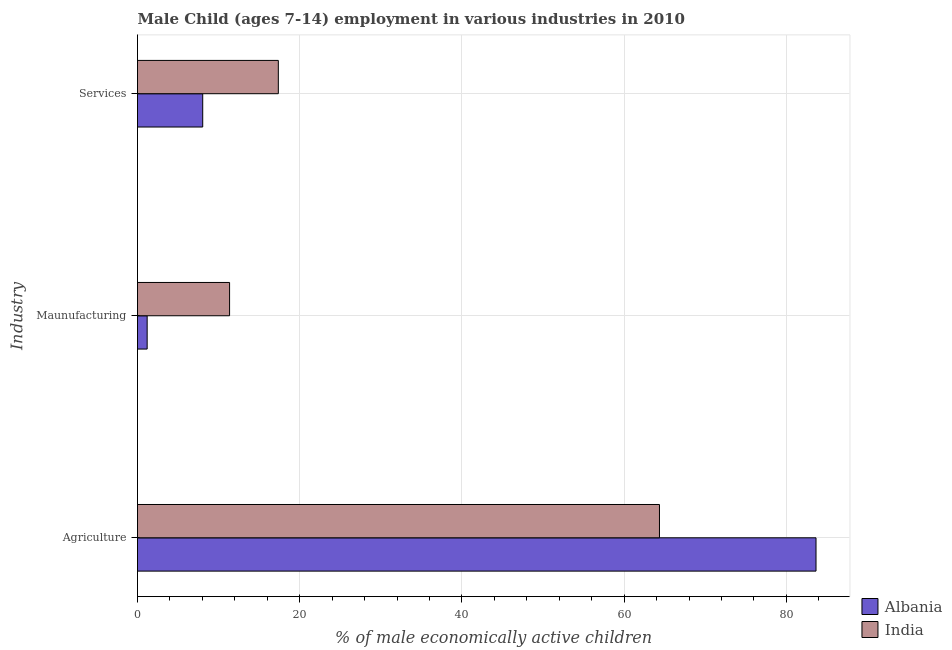What is the label of the 2nd group of bars from the top?
Provide a succinct answer. Maunufacturing. What is the percentage of economically active children in services in Albania?
Provide a short and direct response. 8.04. Across all countries, what is the maximum percentage of economically active children in services?
Keep it short and to the point. 17.36. Across all countries, what is the minimum percentage of economically active children in services?
Make the answer very short. 8.04. In which country was the percentage of economically active children in services minimum?
Provide a succinct answer. Albania. What is the total percentage of economically active children in agriculture in the graph?
Your response must be concise. 148. What is the difference between the percentage of economically active children in agriculture in India and that in Albania?
Your answer should be compact. -19.3. What is the difference between the percentage of economically active children in manufacturing in Albania and the percentage of economically active children in agriculture in India?
Ensure brevity in your answer.  -63.16. What is the difference between the percentage of economically active children in manufacturing and percentage of economically active children in agriculture in India?
Your response must be concise. -53. In how many countries, is the percentage of economically active children in manufacturing greater than 60 %?
Offer a terse response. 0. What is the ratio of the percentage of economically active children in agriculture in Albania to that in India?
Your response must be concise. 1.3. Is the percentage of economically active children in manufacturing in India less than that in Albania?
Offer a very short reply. No. What is the difference between the highest and the second highest percentage of economically active children in manufacturing?
Give a very brief answer. 10.16. What is the difference between the highest and the lowest percentage of economically active children in agriculture?
Your response must be concise. 19.3. In how many countries, is the percentage of economically active children in manufacturing greater than the average percentage of economically active children in manufacturing taken over all countries?
Keep it short and to the point. 1. What does the 1st bar from the top in Services represents?
Keep it short and to the point. India. What does the 2nd bar from the bottom in Services represents?
Make the answer very short. India. How many countries are there in the graph?
Your answer should be compact. 2. What is the difference between two consecutive major ticks on the X-axis?
Offer a terse response. 20. Are the values on the major ticks of X-axis written in scientific E-notation?
Provide a succinct answer. No. Does the graph contain any zero values?
Ensure brevity in your answer.  No. Where does the legend appear in the graph?
Offer a very short reply. Bottom right. How are the legend labels stacked?
Your answer should be compact. Vertical. What is the title of the graph?
Offer a terse response. Male Child (ages 7-14) employment in various industries in 2010. What is the label or title of the X-axis?
Provide a succinct answer. % of male economically active children. What is the label or title of the Y-axis?
Your response must be concise. Industry. What is the % of male economically active children in Albania in Agriculture?
Your answer should be compact. 83.65. What is the % of male economically active children of India in Agriculture?
Ensure brevity in your answer.  64.35. What is the % of male economically active children of Albania in Maunufacturing?
Ensure brevity in your answer.  1.19. What is the % of male economically active children of India in Maunufacturing?
Your answer should be compact. 11.35. What is the % of male economically active children in Albania in Services?
Provide a short and direct response. 8.04. What is the % of male economically active children of India in Services?
Offer a terse response. 17.36. Across all Industry, what is the maximum % of male economically active children in Albania?
Provide a short and direct response. 83.65. Across all Industry, what is the maximum % of male economically active children in India?
Offer a terse response. 64.35. Across all Industry, what is the minimum % of male economically active children of Albania?
Provide a short and direct response. 1.19. Across all Industry, what is the minimum % of male economically active children of India?
Offer a very short reply. 11.35. What is the total % of male economically active children in Albania in the graph?
Provide a short and direct response. 92.88. What is the total % of male economically active children of India in the graph?
Your answer should be compact. 93.06. What is the difference between the % of male economically active children in Albania in Agriculture and that in Maunufacturing?
Provide a succinct answer. 82.46. What is the difference between the % of male economically active children of India in Agriculture and that in Maunufacturing?
Your response must be concise. 53. What is the difference between the % of male economically active children in Albania in Agriculture and that in Services?
Ensure brevity in your answer.  75.61. What is the difference between the % of male economically active children of India in Agriculture and that in Services?
Provide a succinct answer. 46.99. What is the difference between the % of male economically active children of Albania in Maunufacturing and that in Services?
Your answer should be very brief. -6.85. What is the difference between the % of male economically active children in India in Maunufacturing and that in Services?
Your response must be concise. -6.01. What is the difference between the % of male economically active children in Albania in Agriculture and the % of male economically active children in India in Maunufacturing?
Provide a succinct answer. 72.3. What is the difference between the % of male economically active children of Albania in Agriculture and the % of male economically active children of India in Services?
Offer a very short reply. 66.29. What is the difference between the % of male economically active children in Albania in Maunufacturing and the % of male economically active children in India in Services?
Your response must be concise. -16.17. What is the average % of male economically active children in Albania per Industry?
Offer a very short reply. 30.96. What is the average % of male economically active children of India per Industry?
Offer a very short reply. 31.02. What is the difference between the % of male economically active children of Albania and % of male economically active children of India in Agriculture?
Make the answer very short. 19.3. What is the difference between the % of male economically active children in Albania and % of male economically active children in India in Maunufacturing?
Offer a terse response. -10.16. What is the difference between the % of male economically active children in Albania and % of male economically active children in India in Services?
Give a very brief answer. -9.32. What is the ratio of the % of male economically active children of Albania in Agriculture to that in Maunufacturing?
Make the answer very short. 70.29. What is the ratio of the % of male economically active children in India in Agriculture to that in Maunufacturing?
Offer a very short reply. 5.67. What is the ratio of the % of male economically active children of Albania in Agriculture to that in Services?
Provide a short and direct response. 10.4. What is the ratio of the % of male economically active children of India in Agriculture to that in Services?
Keep it short and to the point. 3.71. What is the ratio of the % of male economically active children of Albania in Maunufacturing to that in Services?
Your answer should be compact. 0.15. What is the ratio of the % of male economically active children in India in Maunufacturing to that in Services?
Your response must be concise. 0.65. What is the difference between the highest and the second highest % of male economically active children of Albania?
Ensure brevity in your answer.  75.61. What is the difference between the highest and the second highest % of male economically active children in India?
Keep it short and to the point. 46.99. What is the difference between the highest and the lowest % of male economically active children in Albania?
Your response must be concise. 82.46. What is the difference between the highest and the lowest % of male economically active children in India?
Ensure brevity in your answer.  53. 